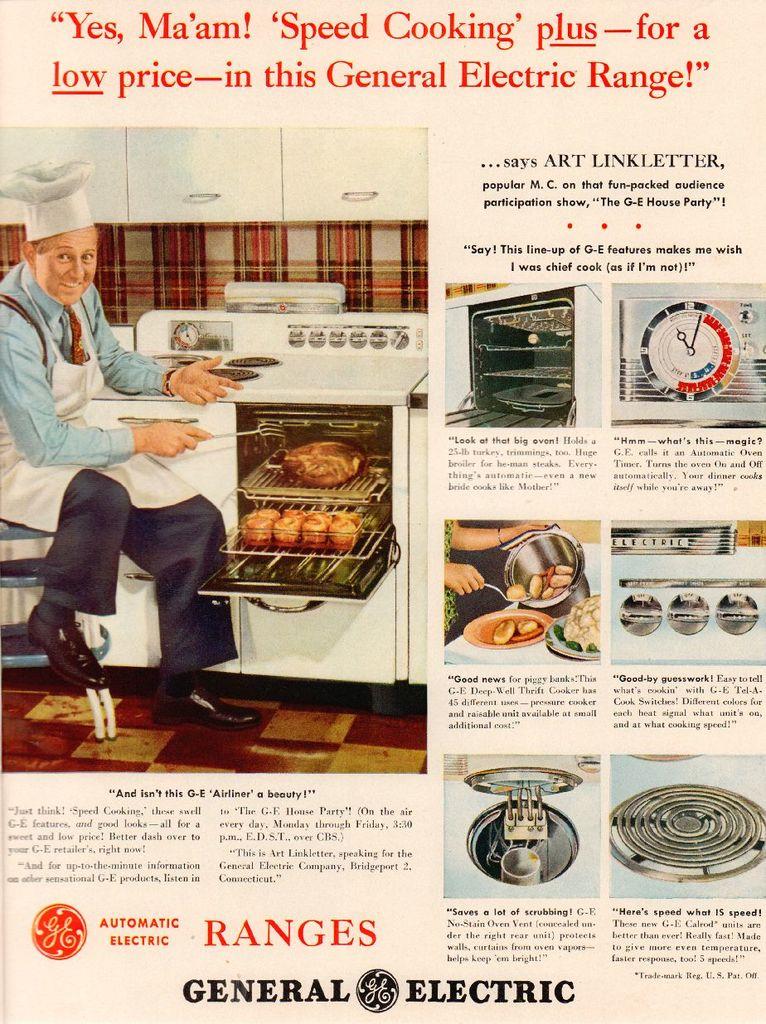What is the name of the cooking company?
Make the answer very short. General electric. What are they advertising for?
Your answer should be very brief. Ranges. 